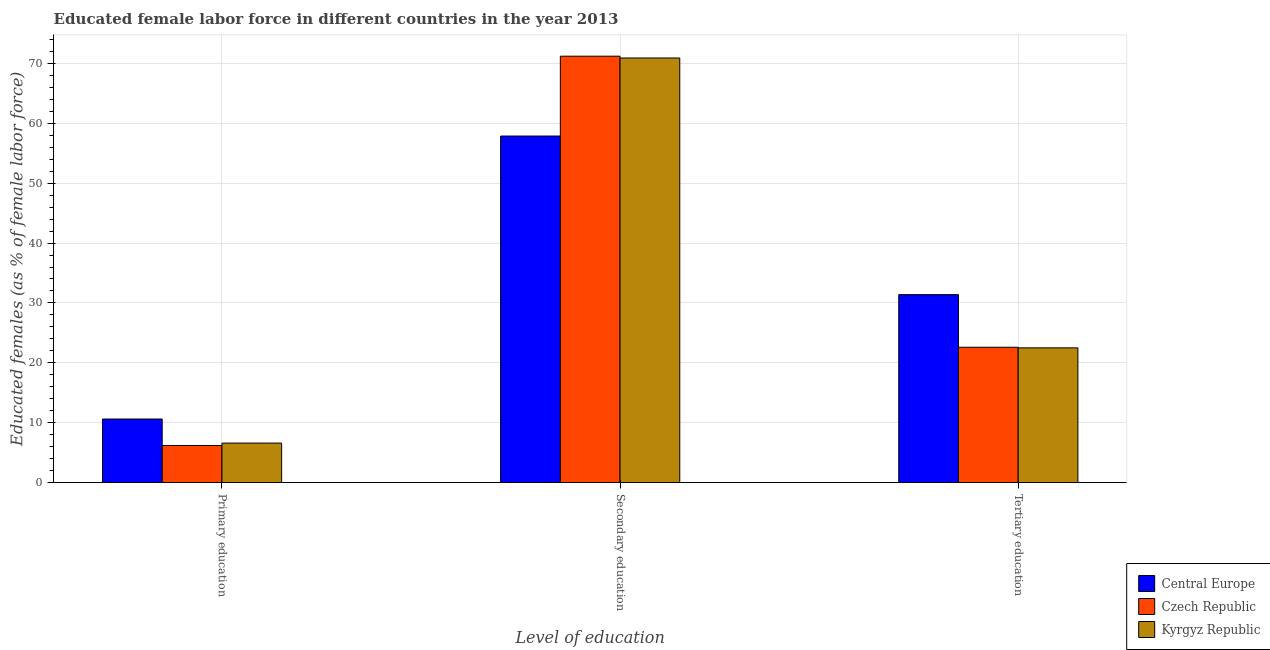Are the number of bars on each tick of the X-axis equal?
Your answer should be compact. Yes. How many bars are there on the 3rd tick from the right?
Keep it short and to the point. 3. What is the label of the 2nd group of bars from the left?
Offer a very short reply. Secondary education. What is the percentage of female labor force who received primary education in Czech Republic?
Provide a short and direct response. 6.2. Across all countries, what is the maximum percentage of female labor force who received secondary education?
Your response must be concise. 71.2. Across all countries, what is the minimum percentage of female labor force who received tertiary education?
Give a very brief answer. 22.5. In which country was the percentage of female labor force who received tertiary education maximum?
Your answer should be very brief. Central Europe. In which country was the percentage of female labor force who received tertiary education minimum?
Your response must be concise. Kyrgyz Republic. What is the total percentage of female labor force who received primary education in the graph?
Ensure brevity in your answer.  23.42. What is the difference between the percentage of female labor force who received secondary education in Central Europe and that in Czech Republic?
Your answer should be very brief. -13.33. What is the difference between the percentage of female labor force who received tertiary education in Czech Republic and the percentage of female labor force who received primary education in Central Europe?
Your answer should be very brief. 11.98. What is the average percentage of female labor force who received secondary education per country?
Your answer should be very brief. 66.66. What is the difference between the percentage of female labor force who received primary education and percentage of female labor force who received tertiary education in Czech Republic?
Ensure brevity in your answer.  -16.4. What is the ratio of the percentage of female labor force who received tertiary education in Central Europe to that in Czech Republic?
Give a very brief answer. 1.39. Is the percentage of female labor force who received tertiary education in Czech Republic less than that in Central Europe?
Provide a short and direct response. Yes. What is the difference between the highest and the second highest percentage of female labor force who received secondary education?
Provide a succinct answer. 0.3. What is the difference between the highest and the lowest percentage of female labor force who received tertiary education?
Your response must be concise. 8.89. Is the sum of the percentage of female labor force who received secondary education in Central Europe and Kyrgyz Republic greater than the maximum percentage of female labor force who received tertiary education across all countries?
Offer a very short reply. Yes. What does the 2nd bar from the left in Secondary education represents?
Your answer should be very brief. Czech Republic. What does the 1st bar from the right in Tertiary education represents?
Give a very brief answer. Kyrgyz Republic. Are all the bars in the graph horizontal?
Ensure brevity in your answer.  No. Does the graph contain any zero values?
Your answer should be compact. No. How many legend labels are there?
Ensure brevity in your answer.  3. What is the title of the graph?
Ensure brevity in your answer.  Educated female labor force in different countries in the year 2013. Does "Uganda" appear as one of the legend labels in the graph?
Keep it short and to the point. No. What is the label or title of the X-axis?
Ensure brevity in your answer.  Level of education. What is the label or title of the Y-axis?
Provide a short and direct response. Educated females (as % of female labor force). What is the Educated females (as % of female labor force) in Central Europe in Primary education?
Keep it short and to the point. 10.62. What is the Educated females (as % of female labor force) of Czech Republic in Primary education?
Offer a very short reply. 6.2. What is the Educated females (as % of female labor force) of Kyrgyz Republic in Primary education?
Make the answer very short. 6.6. What is the Educated females (as % of female labor force) of Central Europe in Secondary education?
Provide a succinct answer. 57.87. What is the Educated females (as % of female labor force) of Czech Republic in Secondary education?
Offer a terse response. 71.2. What is the Educated females (as % of female labor force) of Kyrgyz Republic in Secondary education?
Ensure brevity in your answer.  70.9. What is the Educated females (as % of female labor force) of Central Europe in Tertiary education?
Your response must be concise. 31.39. What is the Educated females (as % of female labor force) in Czech Republic in Tertiary education?
Give a very brief answer. 22.6. Across all Level of education, what is the maximum Educated females (as % of female labor force) in Central Europe?
Give a very brief answer. 57.87. Across all Level of education, what is the maximum Educated females (as % of female labor force) of Czech Republic?
Offer a terse response. 71.2. Across all Level of education, what is the maximum Educated females (as % of female labor force) in Kyrgyz Republic?
Make the answer very short. 70.9. Across all Level of education, what is the minimum Educated females (as % of female labor force) in Central Europe?
Offer a very short reply. 10.62. Across all Level of education, what is the minimum Educated females (as % of female labor force) in Czech Republic?
Your answer should be compact. 6.2. Across all Level of education, what is the minimum Educated females (as % of female labor force) in Kyrgyz Republic?
Your response must be concise. 6.6. What is the total Educated females (as % of female labor force) of Central Europe in the graph?
Provide a short and direct response. 99.87. What is the difference between the Educated females (as % of female labor force) in Central Europe in Primary education and that in Secondary education?
Ensure brevity in your answer.  -47.25. What is the difference between the Educated females (as % of female labor force) in Czech Republic in Primary education and that in Secondary education?
Your answer should be very brief. -65. What is the difference between the Educated females (as % of female labor force) of Kyrgyz Republic in Primary education and that in Secondary education?
Offer a terse response. -64.3. What is the difference between the Educated females (as % of female labor force) of Central Europe in Primary education and that in Tertiary education?
Your answer should be very brief. -20.77. What is the difference between the Educated females (as % of female labor force) of Czech Republic in Primary education and that in Tertiary education?
Offer a terse response. -16.4. What is the difference between the Educated females (as % of female labor force) in Kyrgyz Republic in Primary education and that in Tertiary education?
Provide a short and direct response. -15.9. What is the difference between the Educated females (as % of female labor force) in Central Europe in Secondary education and that in Tertiary education?
Provide a short and direct response. 26.48. What is the difference between the Educated females (as % of female labor force) in Czech Republic in Secondary education and that in Tertiary education?
Keep it short and to the point. 48.6. What is the difference between the Educated females (as % of female labor force) in Kyrgyz Republic in Secondary education and that in Tertiary education?
Make the answer very short. 48.4. What is the difference between the Educated females (as % of female labor force) of Central Europe in Primary education and the Educated females (as % of female labor force) of Czech Republic in Secondary education?
Your response must be concise. -60.58. What is the difference between the Educated females (as % of female labor force) in Central Europe in Primary education and the Educated females (as % of female labor force) in Kyrgyz Republic in Secondary education?
Offer a terse response. -60.28. What is the difference between the Educated females (as % of female labor force) in Czech Republic in Primary education and the Educated females (as % of female labor force) in Kyrgyz Republic in Secondary education?
Your response must be concise. -64.7. What is the difference between the Educated females (as % of female labor force) of Central Europe in Primary education and the Educated females (as % of female labor force) of Czech Republic in Tertiary education?
Give a very brief answer. -11.98. What is the difference between the Educated females (as % of female labor force) in Central Europe in Primary education and the Educated females (as % of female labor force) in Kyrgyz Republic in Tertiary education?
Your answer should be very brief. -11.88. What is the difference between the Educated females (as % of female labor force) in Czech Republic in Primary education and the Educated females (as % of female labor force) in Kyrgyz Republic in Tertiary education?
Keep it short and to the point. -16.3. What is the difference between the Educated females (as % of female labor force) in Central Europe in Secondary education and the Educated females (as % of female labor force) in Czech Republic in Tertiary education?
Offer a terse response. 35.27. What is the difference between the Educated females (as % of female labor force) in Central Europe in Secondary education and the Educated females (as % of female labor force) in Kyrgyz Republic in Tertiary education?
Provide a succinct answer. 35.37. What is the difference between the Educated females (as % of female labor force) in Czech Republic in Secondary education and the Educated females (as % of female labor force) in Kyrgyz Republic in Tertiary education?
Provide a short and direct response. 48.7. What is the average Educated females (as % of female labor force) in Central Europe per Level of education?
Provide a succinct answer. 33.29. What is the average Educated females (as % of female labor force) of Czech Republic per Level of education?
Give a very brief answer. 33.33. What is the average Educated females (as % of female labor force) of Kyrgyz Republic per Level of education?
Keep it short and to the point. 33.33. What is the difference between the Educated females (as % of female labor force) of Central Europe and Educated females (as % of female labor force) of Czech Republic in Primary education?
Keep it short and to the point. 4.42. What is the difference between the Educated females (as % of female labor force) of Central Europe and Educated females (as % of female labor force) of Kyrgyz Republic in Primary education?
Offer a very short reply. 4.02. What is the difference between the Educated females (as % of female labor force) of Czech Republic and Educated females (as % of female labor force) of Kyrgyz Republic in Primary education?
Give a very brief answer. -0.4. What is the difference between the Educated females (as % of female labor force) of Central Europe and Educated females (as % of female labor force) of Czech Republic in Secondary education?
Offer a terse response. -13.33. What is the difference between the Educated females (as % of female labor force) of Central Europe and Educated females (as % of female labor force) of Kyrgyz Republic in Secondary education?
Offer a terse response. -13.03. What is the difference between the Educated females (as % of female labor force) in Central Europe and Educated females (as % of female labor force) in Czech Republic in Tertiary education?
Ensure brevity in your answer.  8.79. What is the difference between the Educated females (as % of female labor force) of Central Europe and Educated females (as % of female labor force) of Kyrgyz Republic in Tertiary education?
Provide a short and direct response. 8.89. What is the difference between the Educated females (as % of female labor force) in Czech Republic and Educated females (as % of female labor force) in Kyrgyz Republic in Tertiary education?
Give a very brief answer. 0.1. What is the ratio of the Educated females (as % of female labor force) in Central Europe in Primary education to that in Secondary education?
Offer a terse response. 0.18. What is the ratio of the Educated females (as % of female labor force) of Czech Republic in Primary education to that in Secondary education?
Your answer should be very brief. 0.09. What is the ratio of the Educated females (as % of female labor force) of Kyrgyz Republic in Primary education to that in Secondary education?
Your answer should be very brief. 0.09. What is the ratio of the Educated females (as % of female labor force) of Central Europe in Primary education to that in Tertiary education?
Offer a very short reply. 0.34. What is the ratio of the Educated females (as % of female labor force) in Czech Republic in Primary education to that in Tertiary education?
Ensure brevity in your answer.  0.27. What is the ratio of the Educated females (as % of female labor force) of Kyrgyz Republic in Primary education to that in Tertiary education?
Your answer should be very brief. 0.29. What is the ratio of the Educated females (as % of female labor force) of Central Europe in Secondary education to that in Tertiary education?
Make the answer very short. 1.84. What is the ratio of the Educated females (as % of female labor force) of Czech Republic in Secondary education to that in Tertiary education?
Provide a short and direct response. 3.15. What is the ratio of the Educated females (as % of female labor force) of Kyrgyz Republic in Secondary education to that in Tertiary education?
Offer a very short reply. 3.15. What is the difference between the highest and the second highest Educated females (as % of female labor force) in Central Europe?
Provide a short and direct response. 26.48. What is the difference between the highest and the second highest Educated females (as % of female labor force) in Czech Republic?
Give a very brief answer. 48.6. What is the difference between the highest and the second highest Educated females (as % of female labor force) in Kyrgyz Republic?
Provide a succinct answer. 48.4. What is the difference between the highest and the lowest Educated females (as % of female labor force) of Central Europe?
Offer a terse response. 47.25. What is the difference between the highest and the lowest Educated females (as % of female labor force) of Kyrgyz Republic?
Offer a very short reply. 64.3. 